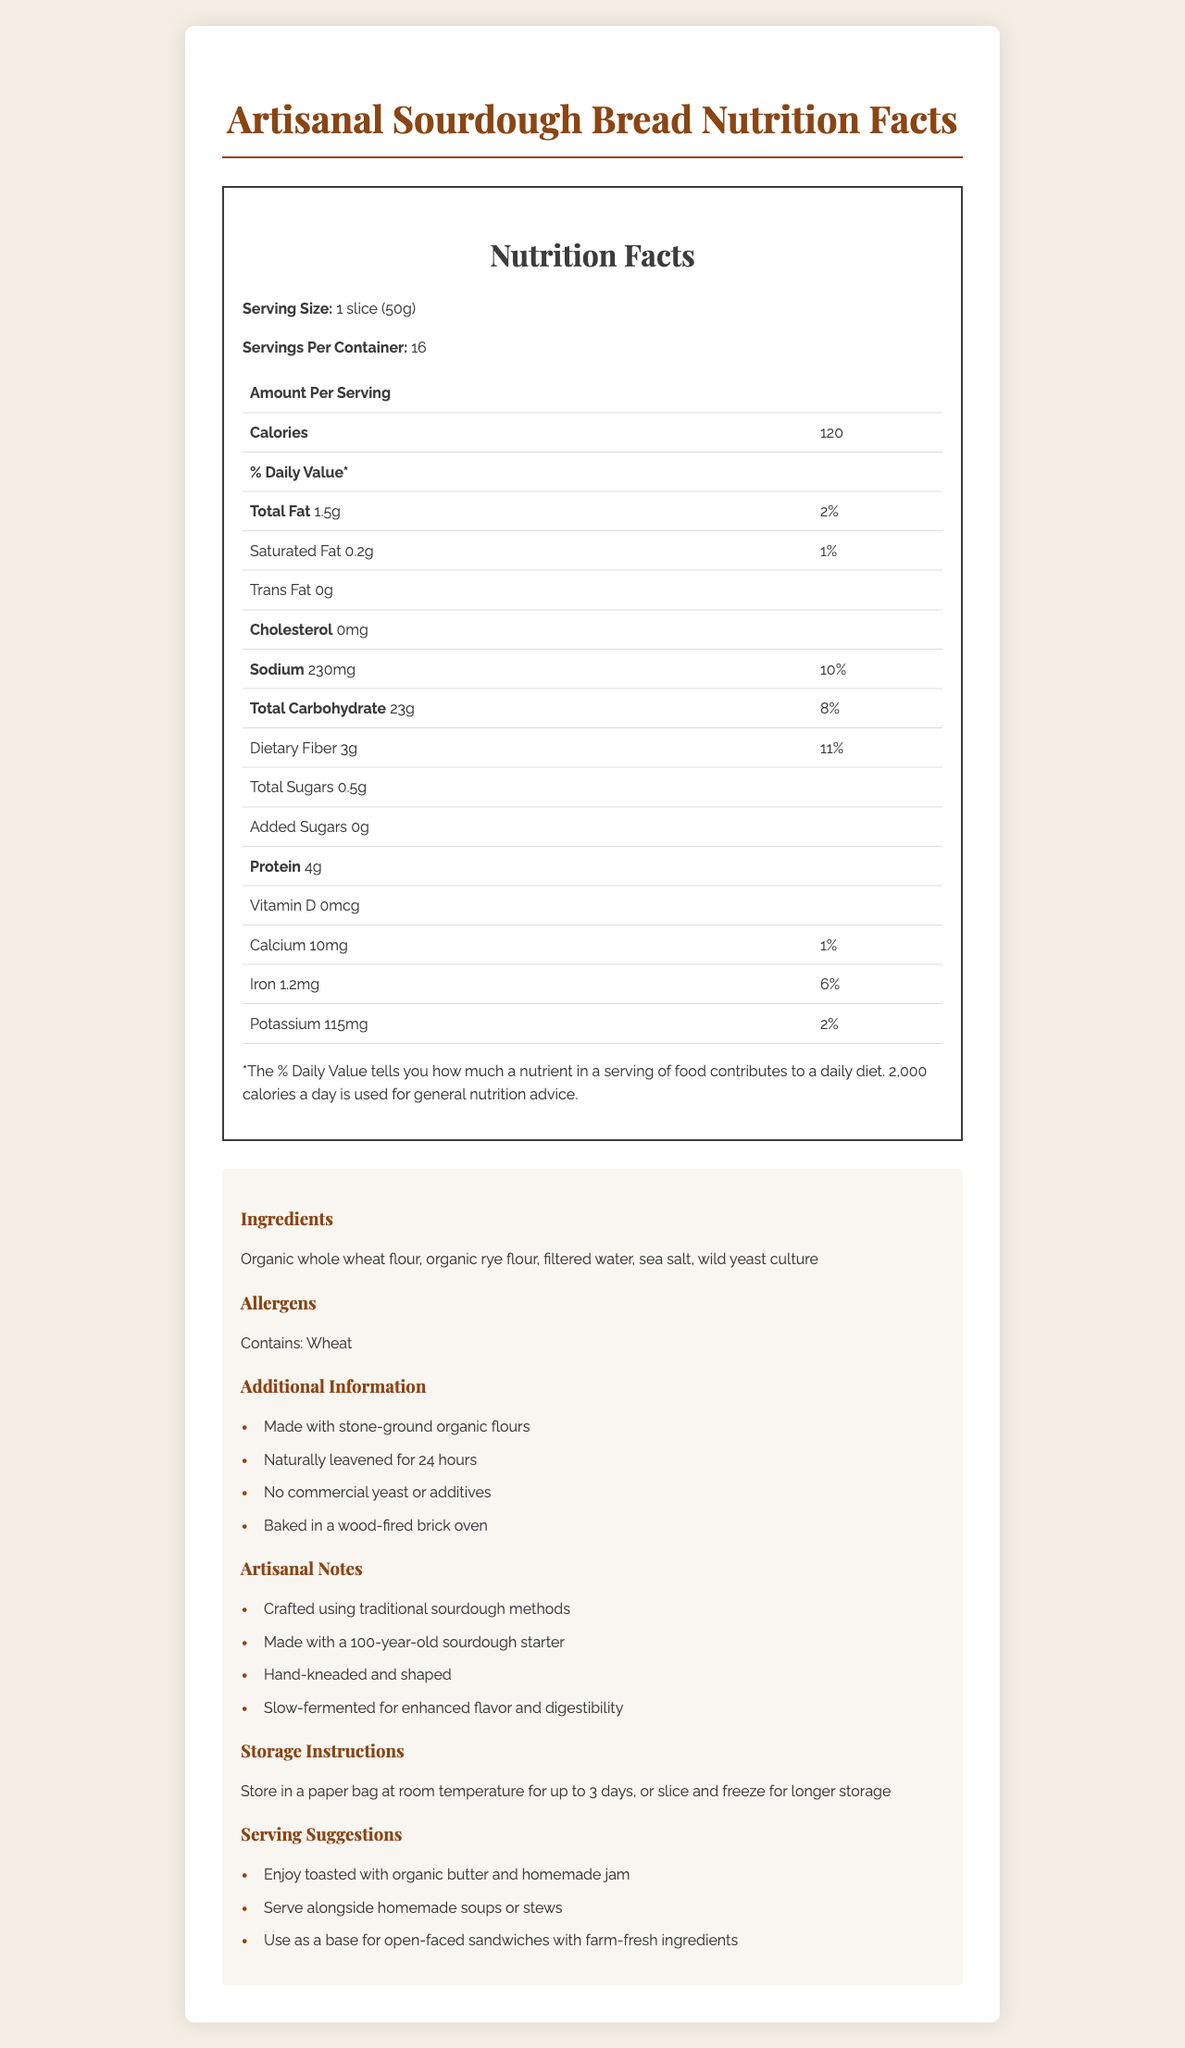what is the serving size for the sourdough bread? The document specifies that the serving size is "1 slice (50g)".
Answer: 1 slice (50g) how many calories are in one serving of the bread? The document states that one serving of the bread contains 120 calories.
Answer: 120 calories name two key ingredients in the sourdough bread. The ingredients listed in the document include organic whole wheat flour and organic rye flour.
Answer: Organic whole wheat flour, organic rye flour what is the total fat content per serving? The document indicates that the total fat content per serving is 1.5g.
Answer: 1.5g which nutrient is present in the highest amount per serving? The document shows that total carbohydrate content per serving is 23g, which is higher than any other nutrient listed.
Answer: Total Carbohydrate how much dietary fiber does one serving contain? The document states that there is 3g of dietary fiber per serving.
Answer: 3g what percentage of the daily value of sodium does one serving provide? A. 2% B. 6% C. 10% The document shows that one serving provides 10% of the daily value of sodium.
Answer: C which of the following is NOT part of the additional information provided? I. Contains artificial preservatives II. Made with stone-ground organic flours III. Naturally leavened for 24 hours The document includes "Made with stone-ground organic flours" and "Naturally leavened for 24 hours" in the additional information, but does not mention "Contains artificial preservatives".
Answer: I is the bread baked with commercial yeast? The document specifies that there is "No commercial yeast" in the additional information section.
Answer: No is this sourdough bread suggested for serving alongside homemade soups or stews? The serving suggestions include serving the bread alongside homemade soups or stews.
Answer: Yes summarize the main idea of this document. The main sections of the document include nutrition facts, ingredients, allergens, additional information, artisanal notes, and serving suggestions, giving a comprehensive overview of the bread.
Answer: The document provides detailed nutrition facts, ingredients, allergens, additional information, artisanal notes, storage instructions, and serving suggestions for homemade sourdough bread made with whole-grain flours. how old is the sourdough starter used in this bread? The artisanal notes indicate that the sourdough starter used is 100 years old.
Answer: 100 years old what is the percentage of the daily value of dietary fiber per serving? The document shows that one serving of the bread provides 11% of the daily value of dietary fiber.
Answer: 11% what are the storage instructions for the bread? The document provides these specific storage instructions for the bread.
Answer: Store in a paper bag at room temperature for up to 3 days, or slice and freeze for longer storage are there any preservatives listed in the ingredients? The ingredients listed are organic whole wheat flour, organic rye flour, filtered water, sea salt, and wild yeast culture, with no preservatives mentioned.
Answer: No what is the primary source of protein in the bread? The document does not provide detailed enough information to determine the primary source of protein in the bread.
Answer: Cannot be determined 